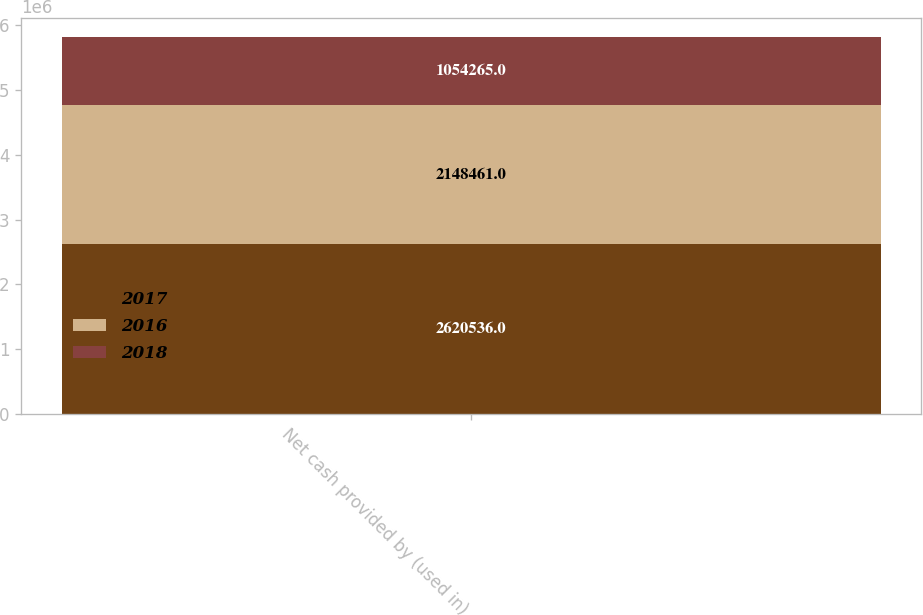<chart> <loc_0><loc_0><loc_500><loc_500><stacked_bar_chart><ecel><fcel>Net cash provided by (used in)<nl><fcel>2017<fcel>2.62054e+06<nl><fcel>2016<fcel>2.14846e+06<nl><fcel>2018<fcel>1.05426e+06<nl></chart> 